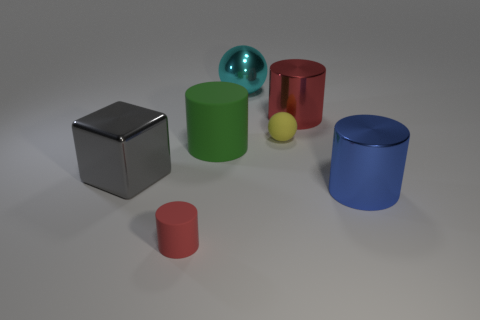What number of things are large metal things to the right of the large cyan shiny thing or large objects left of the tiny red matte cylinder?
Make the answer very short. 3. Does the yellow sphere in front of the large cyan ball have the same material as the green thing?
Provide a succinct answer. Yes. There is a cylinder that is both to the right of the small rubber sphere and in front of the tiny yellow ball; what material is it?
Offer a terse response. Metal. What color is the small thing right of the big cyan object to the left of the large red thing?
Your response must be concise. Yellow. What is the material of the blue object that is the same shape as the red matte thing?
Offer a terse response. Metal. The ball that is behind the small yellow matte thing that is on the right side of the shiny object that is on the left side of the small rubber cylinder is what color?
Keep it short and to the point. Cyan. How many things are large things or large yellow shiny cylinders?
Provide a succinct answer. 5. What number of yellow objects have the same shape as the cyan thing?
Ensure brevity in your answer.  1. Are the green thing and the cylinder that is in front of the blue object made of the same material?
Provide a short and direct response. Yes. The blue cylinder that is the same material as the large cyan sphere is what size?
Your answer should be very brief. Large. 